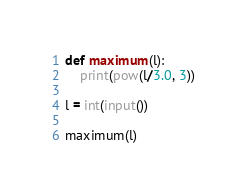<code> <loc_0><loc_0><loc_500><loc_500><_Python_>def maximum(l):
    print(pow(l/3.0, 3))

l = int(input())

maximum(l)</code> 